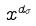<formula> <loc_0><loc_0><loc_500><loc_500>x ^ { d _ { \sigma } }</formula> 